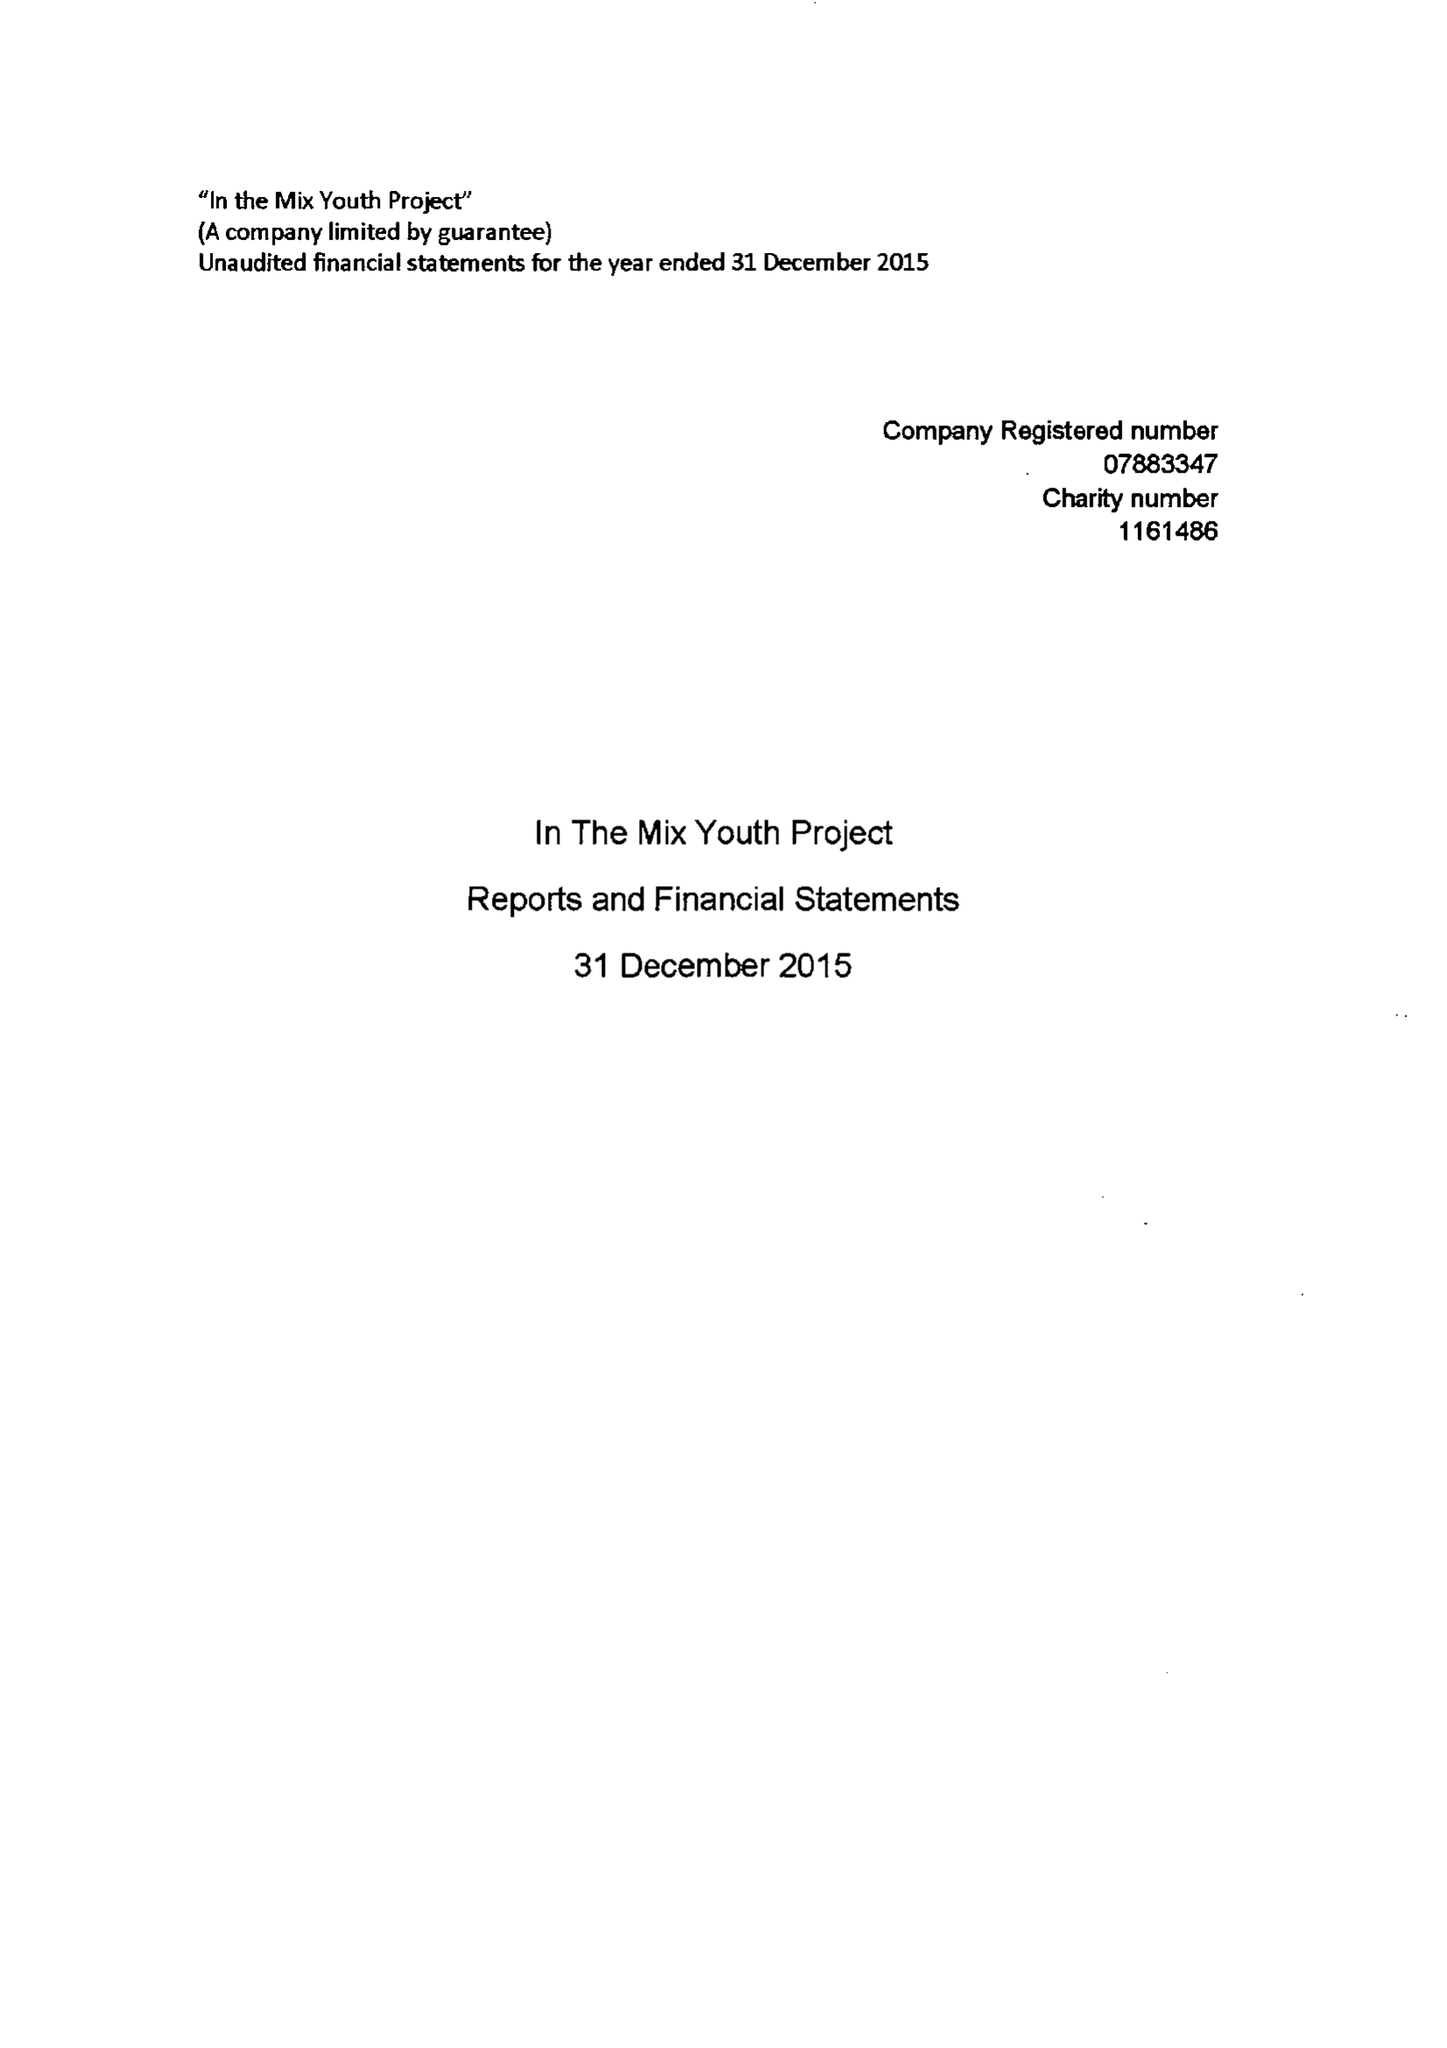What is the value for the charity_number?
Answer the question using a single word or phrase. 1161486 